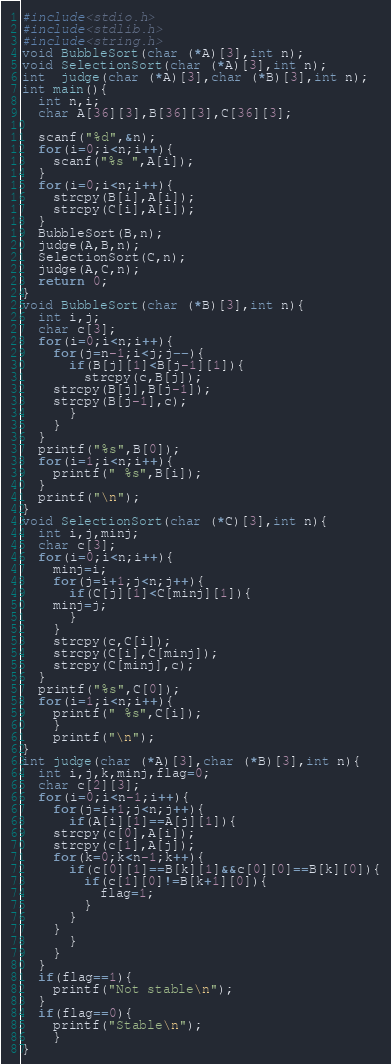Convert code to text. <code><loc_0><loc_0><loc_500><loc_500><_C_>#include<stdio.h>
#include<stdlib.h>
#include<string.h>
void BubbleSort(char (*A)[3],int n);
void SelectionSort(char (*A)[3],int n);
int  judge(char (*A)[3],char (*B)[3],int n);
int main(){
  int n,i;
  char A[36][3],B[36][3],C[36][3];

  scanf("%d",&n);
  for(i=0;i<n;i++){
    scanf("%s ",A[i]);
  }
  for(i=0;i<n;i++){
    strcpy(B[i],A[i]);
    strcpy(C[i],A[i]);
  }
  BubbleSort(B,n);
  judge(A,B,n);
  SelectionSort(C,n);
  judge(A,C,n);
  return 0;
}
void BubbleSort(char (*B)[3],int n){
  int i,j;
  char c[3];
  for(i=0;i<n;i++){
    for(j=n-1;i<j;j--){
      if(B[j][1]<B[j-1][1]){
      	strcpy(c,B[j]);
	strcpy(B[j],B[j-1]);
	strcpy(B[j-1],c);
      }
    }
  }
  printf("%s",B[0]);
  for(i=1;i<n;i++){
    printf(" %s",B[i]);
  }
  printf("\n");
}
void SelectionSort(char (*C)[3],int n){
  int i,j,minj;
  char c[3];
  for(i=0;i<n;i++){
    minj=i;
    for(j=i+1;j<n;j++){
      if(C[j][1]<C[minj][1]){
	minj=j;
      }
    }
    strcpy(c,C[i]);
    strcpy(C[i],C[minj]);
    strcpy(C[minj],c);
  }
  printf("%s",C[0]);
  for(i=1;i<n;i++){
    printf(" %s",C[i]);
	}
	printf("\n");
}
int judge(char (*A)[3],char (*B)[3],int n){
  int i,j,k,minj,flag=0;
  char c[2][3];
  for(i=0;i<n-1;i++){
    for(j=i+1;j<n;j++){
      if(A[i][1]==A[j][1]){
	strcpy(c[0],A[i]);
	strcpy(c[1],A[j]);
	for(k=0;k<n-1;k++){
	  if(c[0][1]==B[k][1]&&c[0][0]==B[k][0]){
	    if(c[1][0]!=B[k+1][0]){
	      flag=1;
	    }
	  }
	}
      }
    }
  }
  if(flag==1){
    printf("Not stable\n");
  }
  if(flag==0){
    printf("Stable\n");
    }
}

</code> 